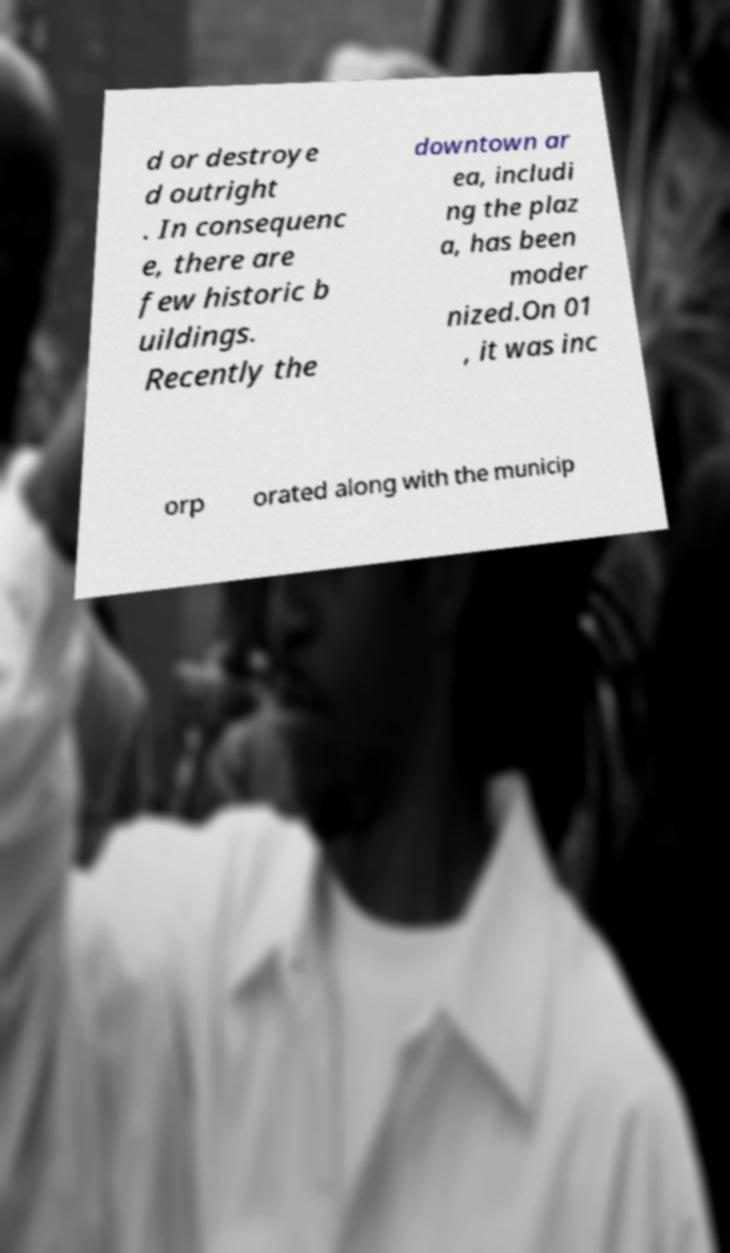I need the written content from this picture converted into text. Can you do that? d or destroye d outright . In consequenc e, there are few historic b uildings. Recently the downtown ar ea, includi ng the plaz a, has been moder nized.On 01 , it was inc orp orated along with the municip 